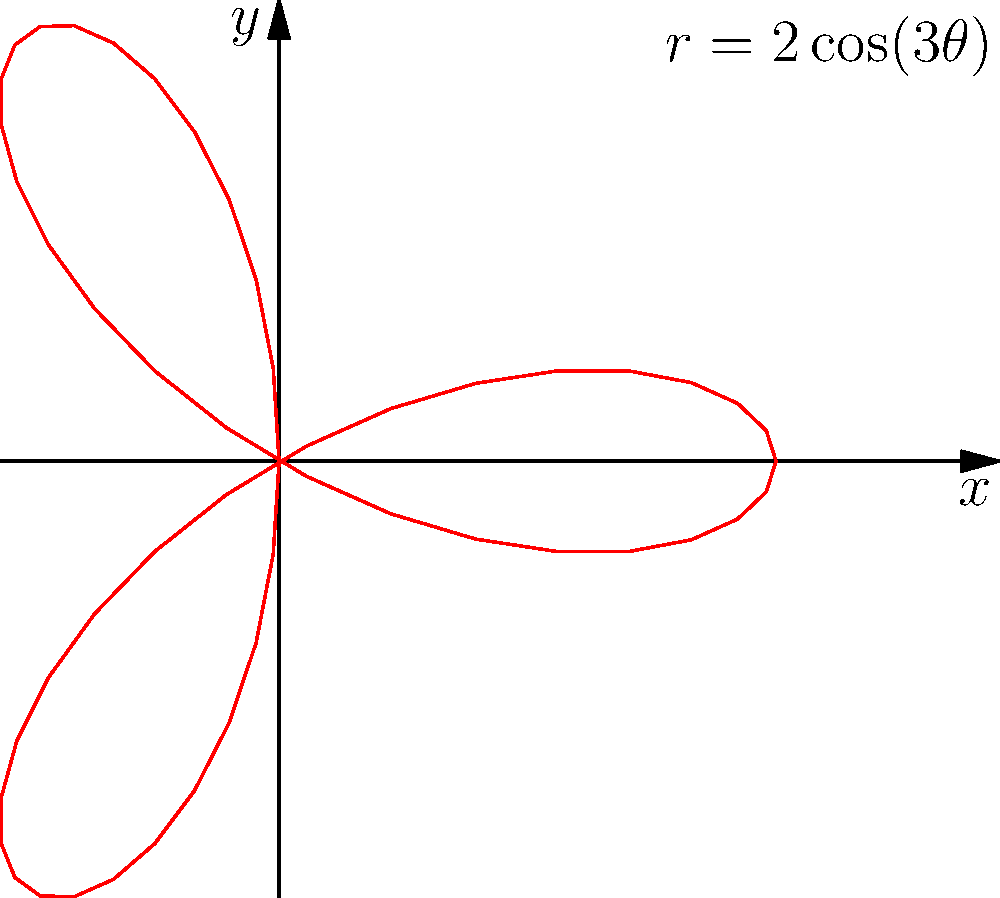You're tasked with plotting the polar curve $r = 2\cos(3\theta)$ using JSON-RPC. Which JSON-RPC method would you use to send the plot data to the server, and what key components should be included in the request object? To plot the polar curve $r = 2\cos(3\theta)$ using JSON-RPC, follow these steps:

1. Choose an appropriate JSON-RPC method:
   The method name could be something like "plot_polar_curve".

2. Create a request object with the following key components:
   a) "jsonrpc": "2.0" (specifying the JSON-RPC version)
   b) "method": "plot_polar_curve" (the method name we chose)
   c) "params": An object containing the curve details:
      - "equation": "r = 2*cos(3*theta)" (the polar equation as a string)
      - "theta_range": [0, 2*Math.PI] (the range for theta)
      - "points": 100 (number of points to calculate for smooth plotting)
   d) "id": A unique identifier for the request (e.g., 1)

3. Send the JSON-RPC request to the server:
   ```json
   {
     "jsonrpc": "2.0",
     "method": "plot_polar_curve",
     "params": {
       "equation": "r = 2*cos(3*theta)",
       "theta_range": [0, 6.283185307179586],
       "points": 100
     },
     "id": 1
   }
   ```

The server would then process this request, generate the plot, and send back a response with the result (which could be an image URL or plot data).
Answer: Method: "plot_polar_curve"; Key components: jsonrpc version, method name, params (equation, theta_range, points), and request id. 